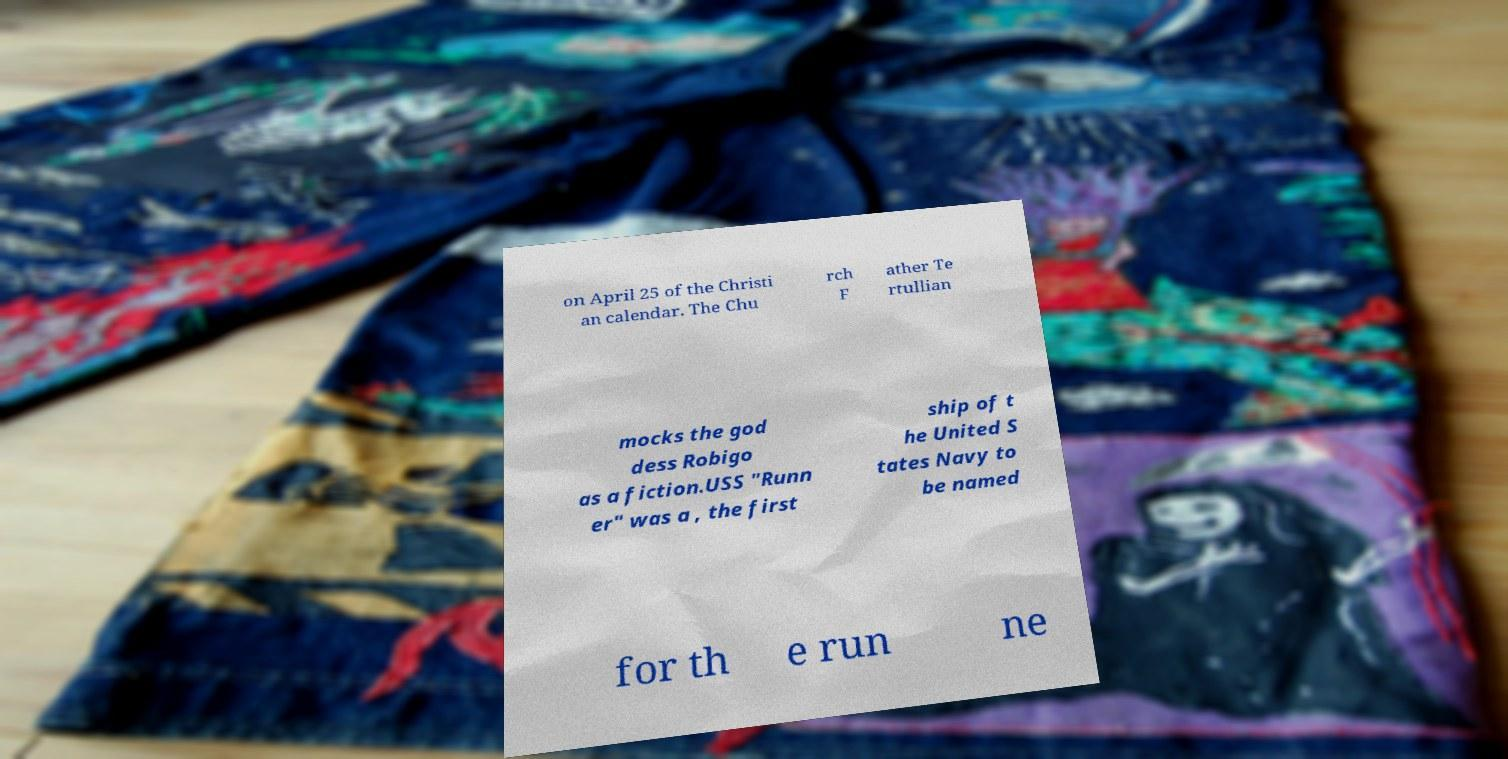Please identify and transcribe the text found in this image. on April 25 of the Christi an calendar. The Chu rch F ather Te rtullian mocks the god dess Robigo as a fiction.USS "Runn er" was a , the first ship of t he United S tates Navy to be named for th e run ne 